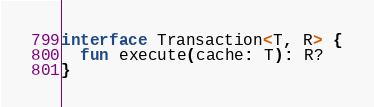Convert code to text. <code><loc_0><loc_0><loc_500><loc_500><_Kotlin_>interface Transaction<T, R> {
  fun execute(cache: T): R?
}</code> 